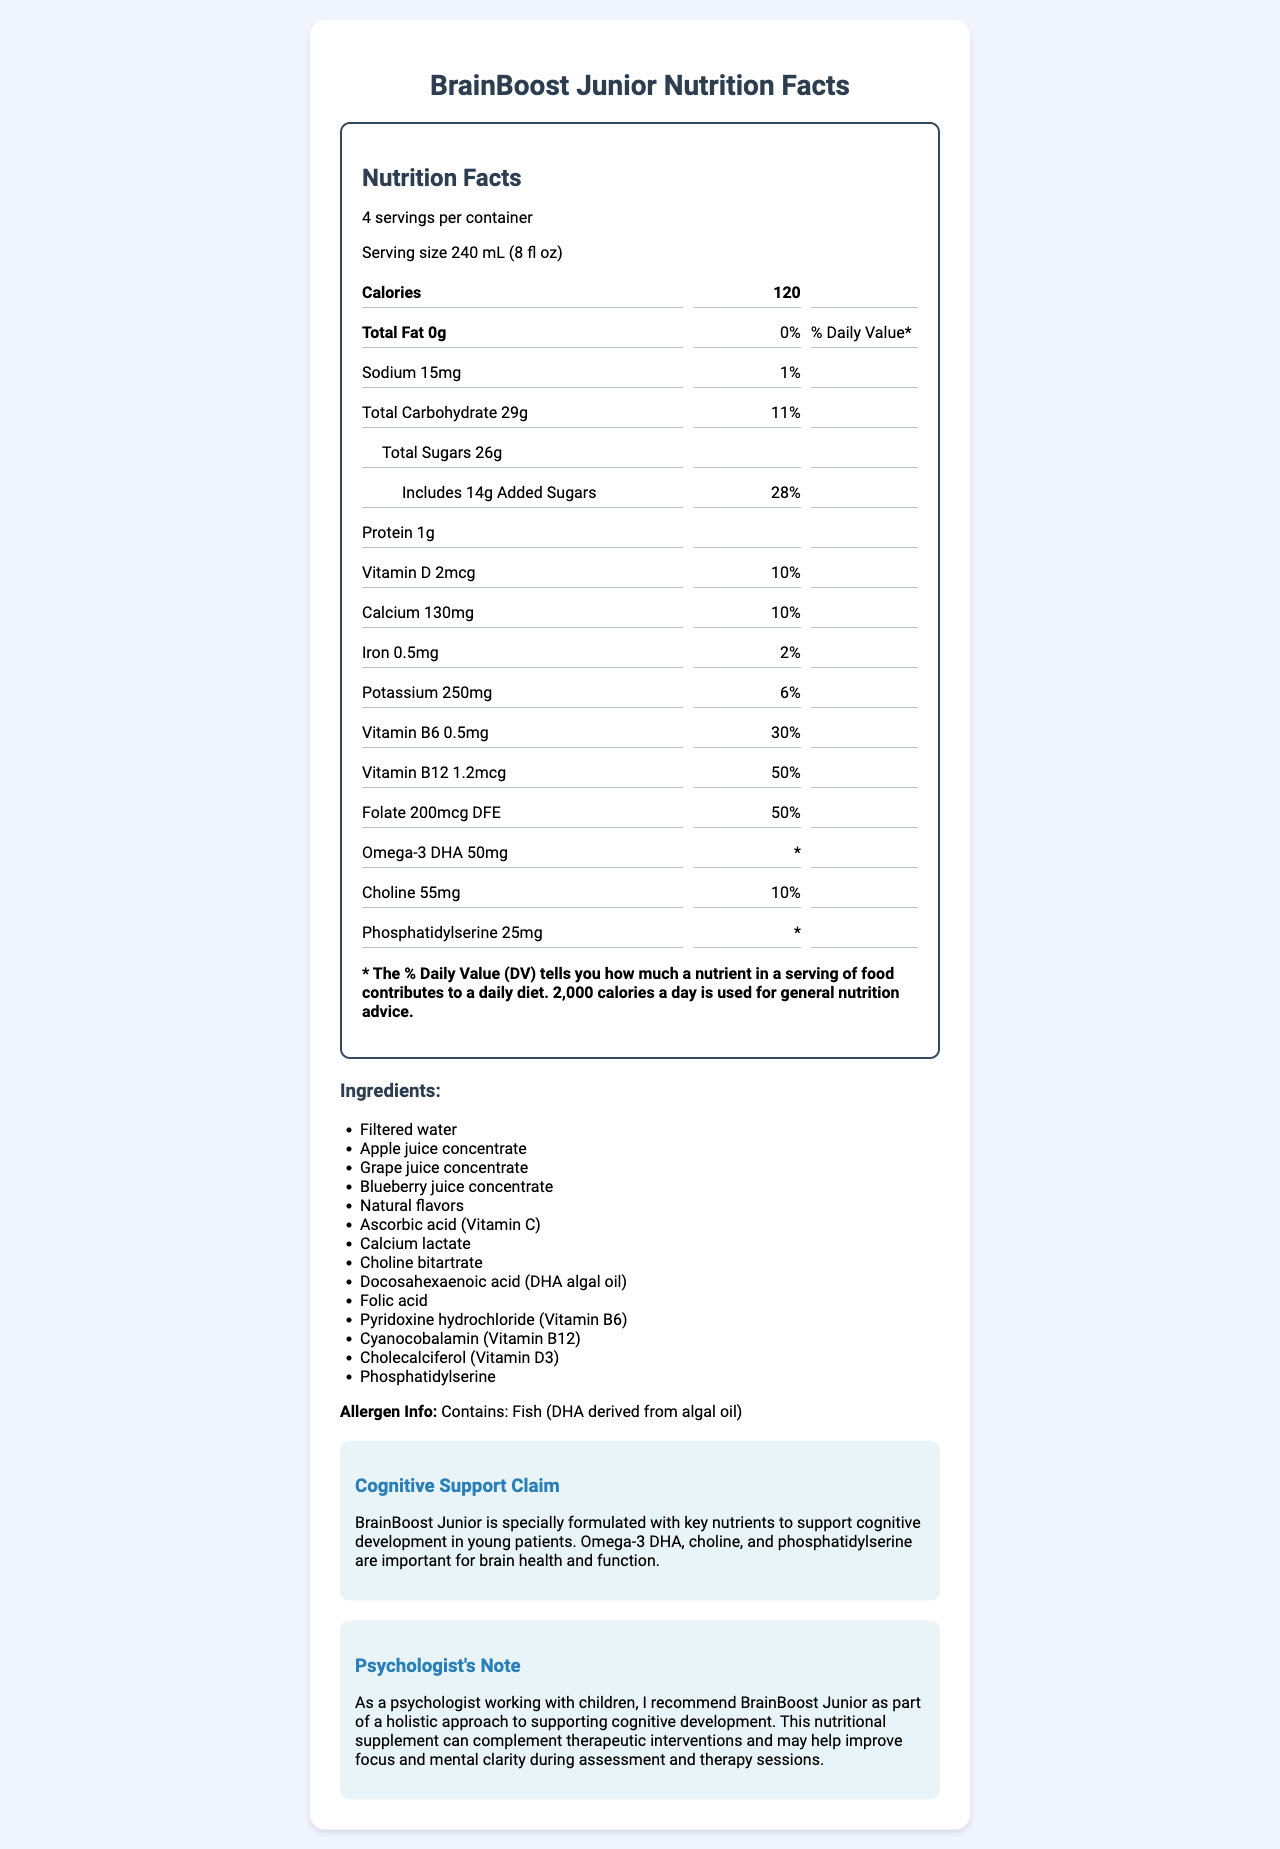what is the serving size for BrainBoost Junior? The serving size is clearly indicated at the top of the Nutrition Facts label as "240 mL (8 fl oz)".
Answer: 240 mL (8 fl oz) how many calories are there in one serving? The calories per serving are listed as "120" near the top of the Nutrition Facts section.
Answer: 120 how much total fat is in one serving? The amount of total fat per serving is shown as "0g".
Answer: 0g what percentage of the daily value of vitamin B12 does one serving provide? Under the vitamins section, vitamin B12 is shown to provide "50%" of the daily value per serving.
Answer: 50% what is the main purpose of BrainBoost Junior according to the Cognitive Support Claim? The Cognitive Support Claim states that the product is formulated with key nutrients to support cognitive development in young patients.
Answer: To support cognitive development in young patients what are the three key nutrients in BrainBoost Junior mentioned for cognitive support? These key nutrients are listed in the Cognitive Support Claim section.
Answer: Omega-3 DHA, choline, phosphatidylserine how many mg of choline does one serving contain? The amount of choline per serving is indicated as "55mg" in the Nutrition Facts section.
Answer: 55mg what is the allergen information provided for BrainBoost Junior? The allergen information is clearly stated as "Contains: Fish (DHA derived from algal oil)".
Answer: Contains: Fish (DHA derived from algal oil) what is the recommended daily calorie intake used for general nutrition advice according to the footnote? The footnote explains that 2,000 calories a day is used for general nutrition advice.
Answer: 2,000 calories how many servings are in one container of BrainBoost Junior? A. 2 B. 4 C. 6 D. 8 The label states there are "4 servings per container".
Answer: B. 4 what is the daily value percentage of added sugars for one serving? I. 10% II. 14% III. 20% IV. 28% The added sugars contribute "28%" of the daily value in one serving.
Answer: IV. 28% does BrainBoost Junior contain any proteins? The Nutrition Facts label lists "Protein 1g", indicating the presence of proteins.
Answer: Yes is BrainBoost Junior a good source of iron? One serving of BrainBoost Junior provides "2%" of the daily value for iron, which is a low percentage.
Answer: No summarize the main idea of the document. The document primarily describes the nutritional content and intended benefits of BrainBoost Junior juice for cognitive support in children.
Answer: BrainBoost Junior is a vitamin-fortified juice formulated to support cognitive development in children. It contains various nutrients such as Omega-3 DHA, choline, and phosphatidylserine, and offers 120 calories per serving with 4 servings per container. The product is intended to be used as part of a holistic approach to improving focus and mental clarity during assessments and therapy. how many mg of calcium are in one serving of BrainBoost Junior? The amount of calcium is listed as "130mg" per serving, but this question is to identify an unanswerable question based on other provided visual information that lacks additional context.
Answer: Cannot be determined 